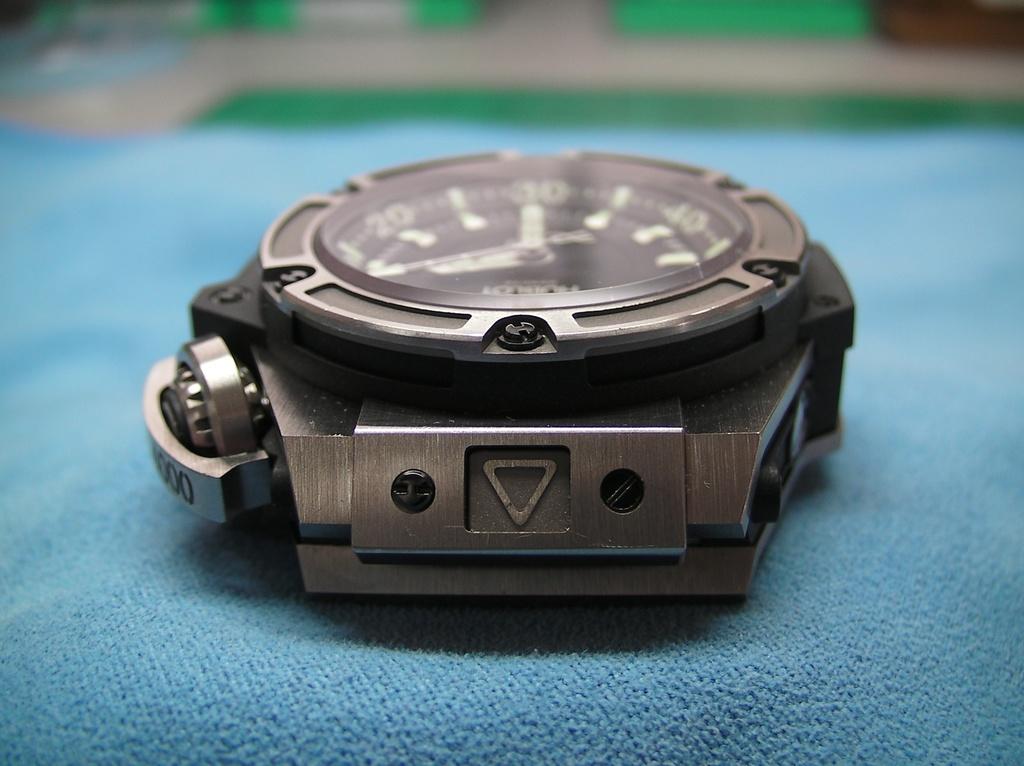Is the watch brand visible?
Ensure brevity in your answer.  Answering does not require reading text in the image. 